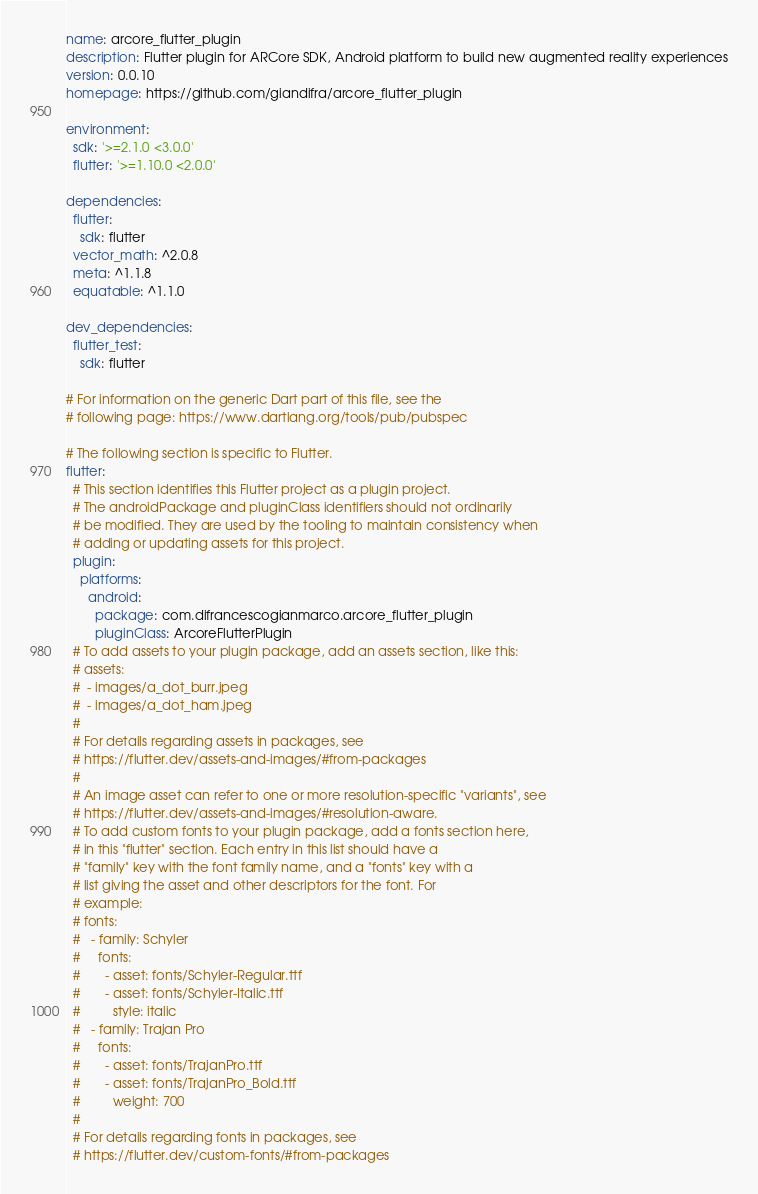<code> <loc_0><loc_0><loc_500><loc_500><_YAML_>name: arcore_flutter_plugin
description: Flutter plugin for ARCore SDK, Android platform to build new augmented reality experiences
version: 0.0.10
homepage: https://github.com/giandifra/arcore_flutter_plugin

environment:
  sdk: '>=2.1.0 <3.0.0'
  flutter: '>=1.10.0 <2.0.0'

dependencies:
  flutter:
    sdk: flutter
  vector_math: ^2.0.8
  meta: ^1.1.8
  equatable: ^1.1.0

dev_dependencies:
  flutter_test:
    sdk: flutter

# For information on the generic Dart part of this file, see the
# following page: https://www.dartlang.org/tools/pub/pubspec

# The following section is specific to Flutter.
flutter:
  # This section identifies this Flutter project as a plugin project.
  # The androidPackage and pluginClass identifiers should not ordinarily
  # be modified. They are used by the tooling to maintain consistency when
  # adding or updating assets for this project.
  plugin:
    platforms:
      android:
        package: com.difrancescogianmarco.arcore_flutter_plugin
        pluginClass: ArcoreFlutterPlugin
  # To add assets to your plugin package, add an assets section, like this:
  # assets:
  #  - images/a_dot_burr.jpeg
  #  - images/a_dot_ham.jpeg
  #
  # For details regarding assets in packages, see
  # https://flutter.dev/assets-and-images/#from-packages
  #
  # An image asset can refer to one or more resolution-specific "variants", see
  # https://flutter.dev/assets-and-images/#resolution-aware.
  # To add custom fonts to your plugin package, add a fonts section here,
  # in this "flutter" section. Each entry in this list should have a
  # "family" key with the font family name, and a "fonts" key with a
  # list giving the asset and other descriptors for the font. For
  # example:
  # fonts:
  #   - family: Schyler
  #     fonts:
  #       - asset: fonts/Schyler-Regular.ttf
  #       - asset: fonts/Schyler-Italic.ttf
  #         style: italic
  #   - family: Trajan Pro
  #     fonts:
  #       - asset: fonts/TrajanPro.ttf
  #       - asset: fonts/TrajanPro_Bold.ttf
  #         weight: 700
  #
  # For details regarding fonts in packages, see
  # https://flutter.dev/custom-fonts/#from-packages
</code> 